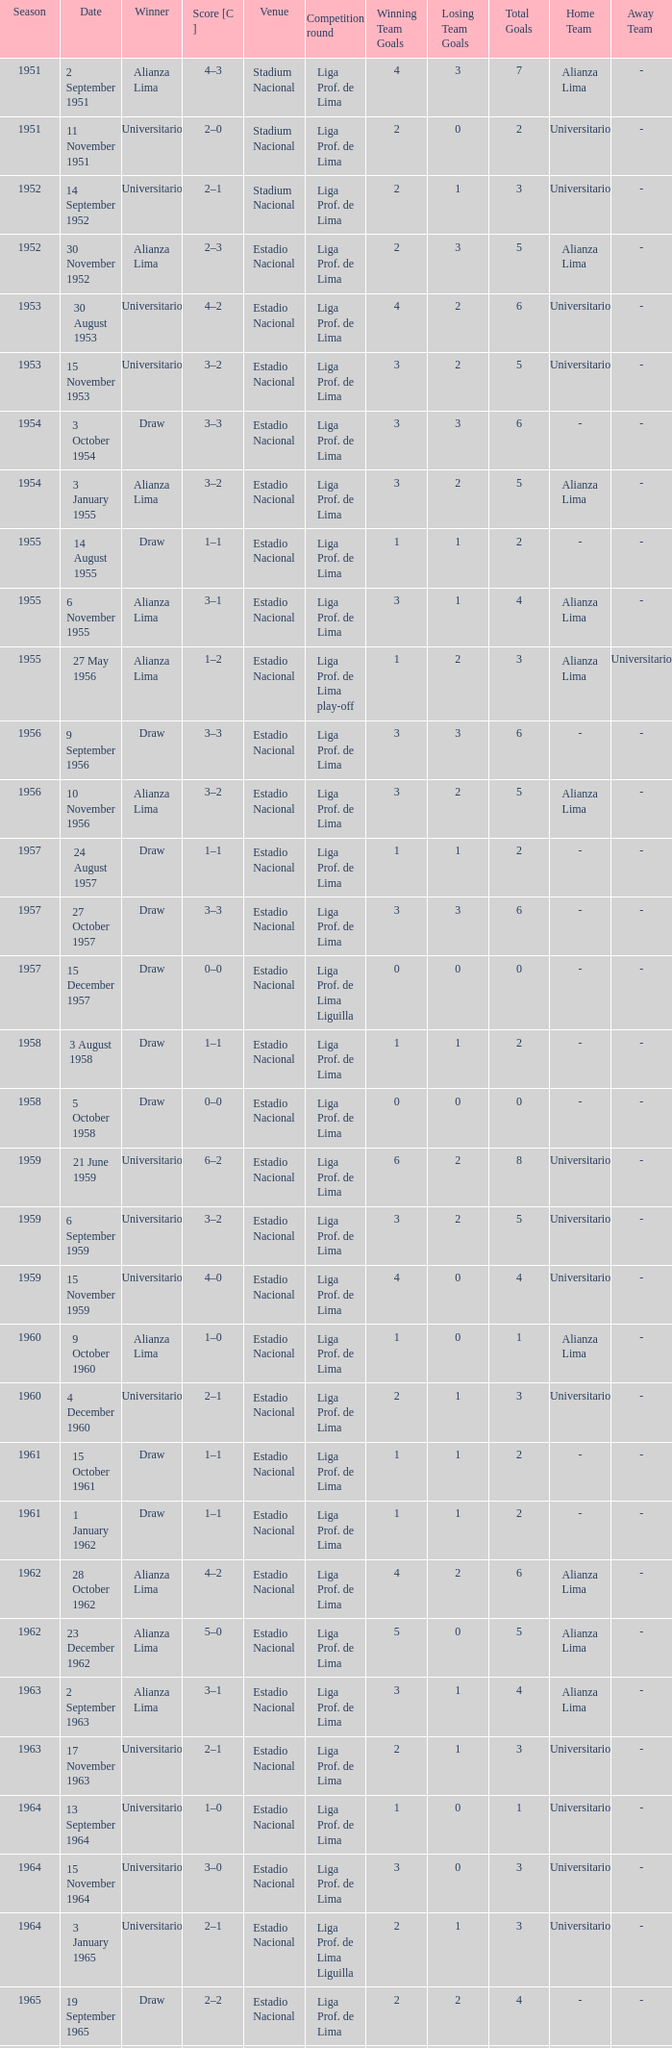What is the score of the event that Alianza Lima won in 1965? 1–0. 